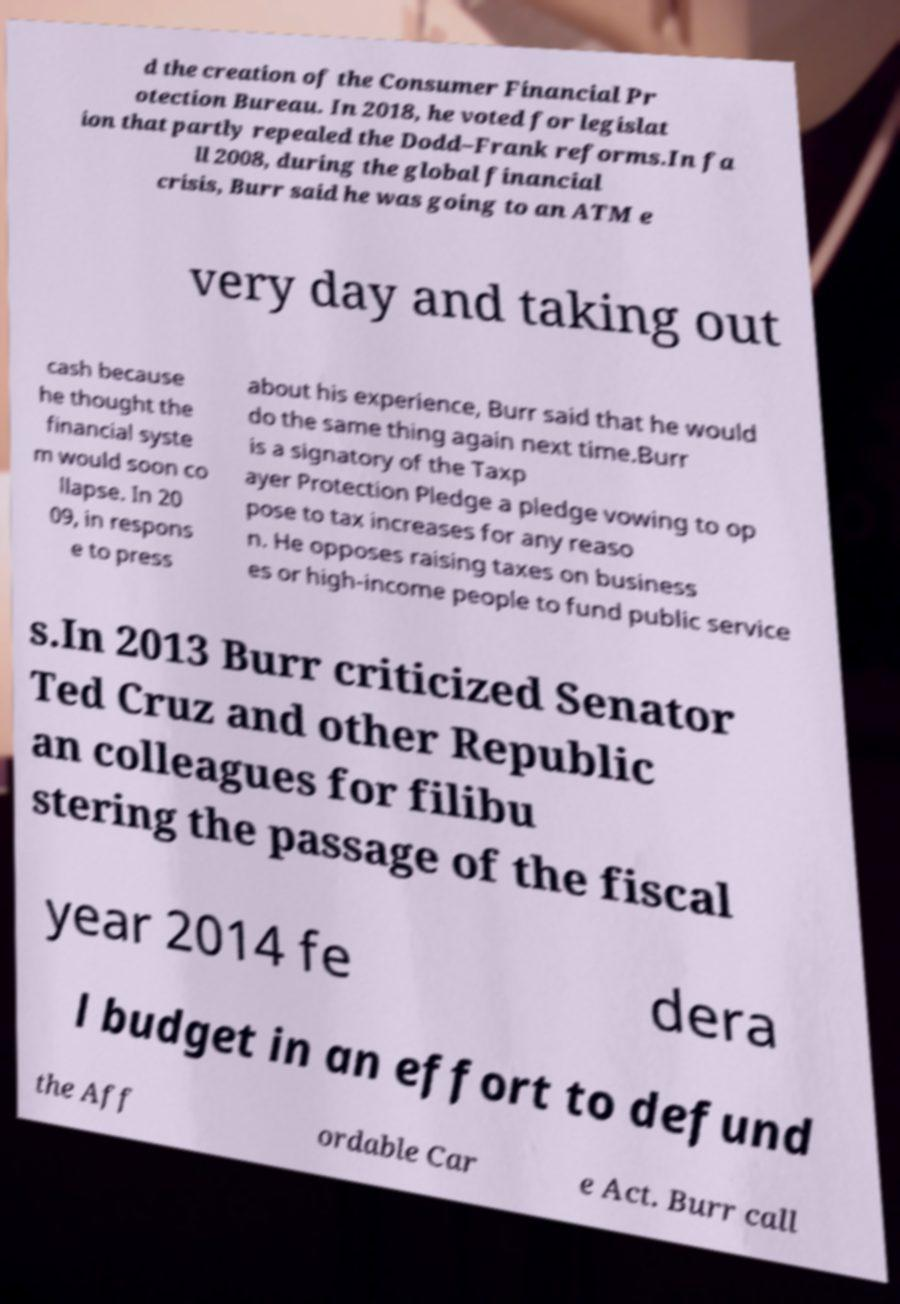What messages or text are displayed in this image? I need them in a readable, typed format. d the creation of the Consumer Financial Pr otection Bureau. In 2018, he voted for legislat ion that partly repealed the Dodd–Frank reforms.In fa ll 2008, during the global financial crisis, Burr said he was going to an ATM e very day and taking out cash because he thought the financial syste m would soon co llapse. In 20 09, in respons e to press about his experience, Burr said that he would do the same thing again next time.Burr is a signatory of the Taxp ayer Protection Pledge a pledge vowing to op pose to tax increases for any reaso n. He opposes raising taxes on business es or high-income people to fund public service s.In 2013 Burr criticized Senator Ted Cruz and other Republic an colleagues for filibu stering the passage of the fiscal year 2014 fe dera l budget in an effort to defund the Aff ordable Car e Act. Burr call 